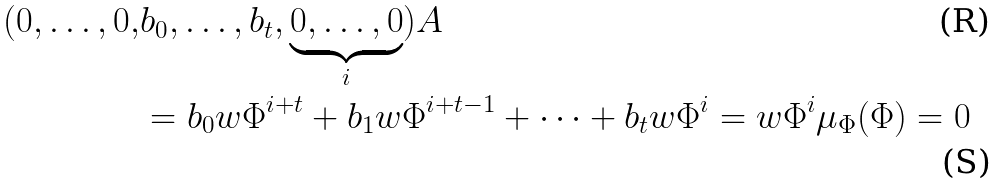Convert formula to latex. <formula><loc_0><loc_0><loc_500><loc_500>( 0 , \dots , 0 , & b _ { 0 } , \dots , b _ { t } , \underbrace { 0 , \dots , 0 } _ { i } ) A \\ & = b _ { 0 } w \Phi ^ { i + t } + b _ { 1 } w \Phi ^ { i + t - 1 } + \dots + b _ { t } w \Phi ^ { i } = w \Phi ^ { i } \mu _ { \Phi } ( \Phi ) = 0</formula> 